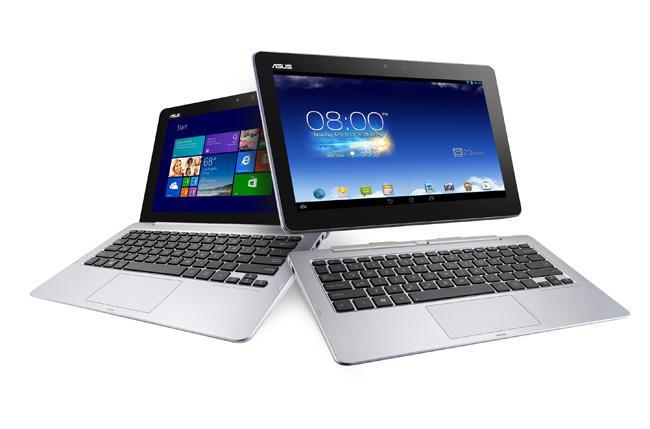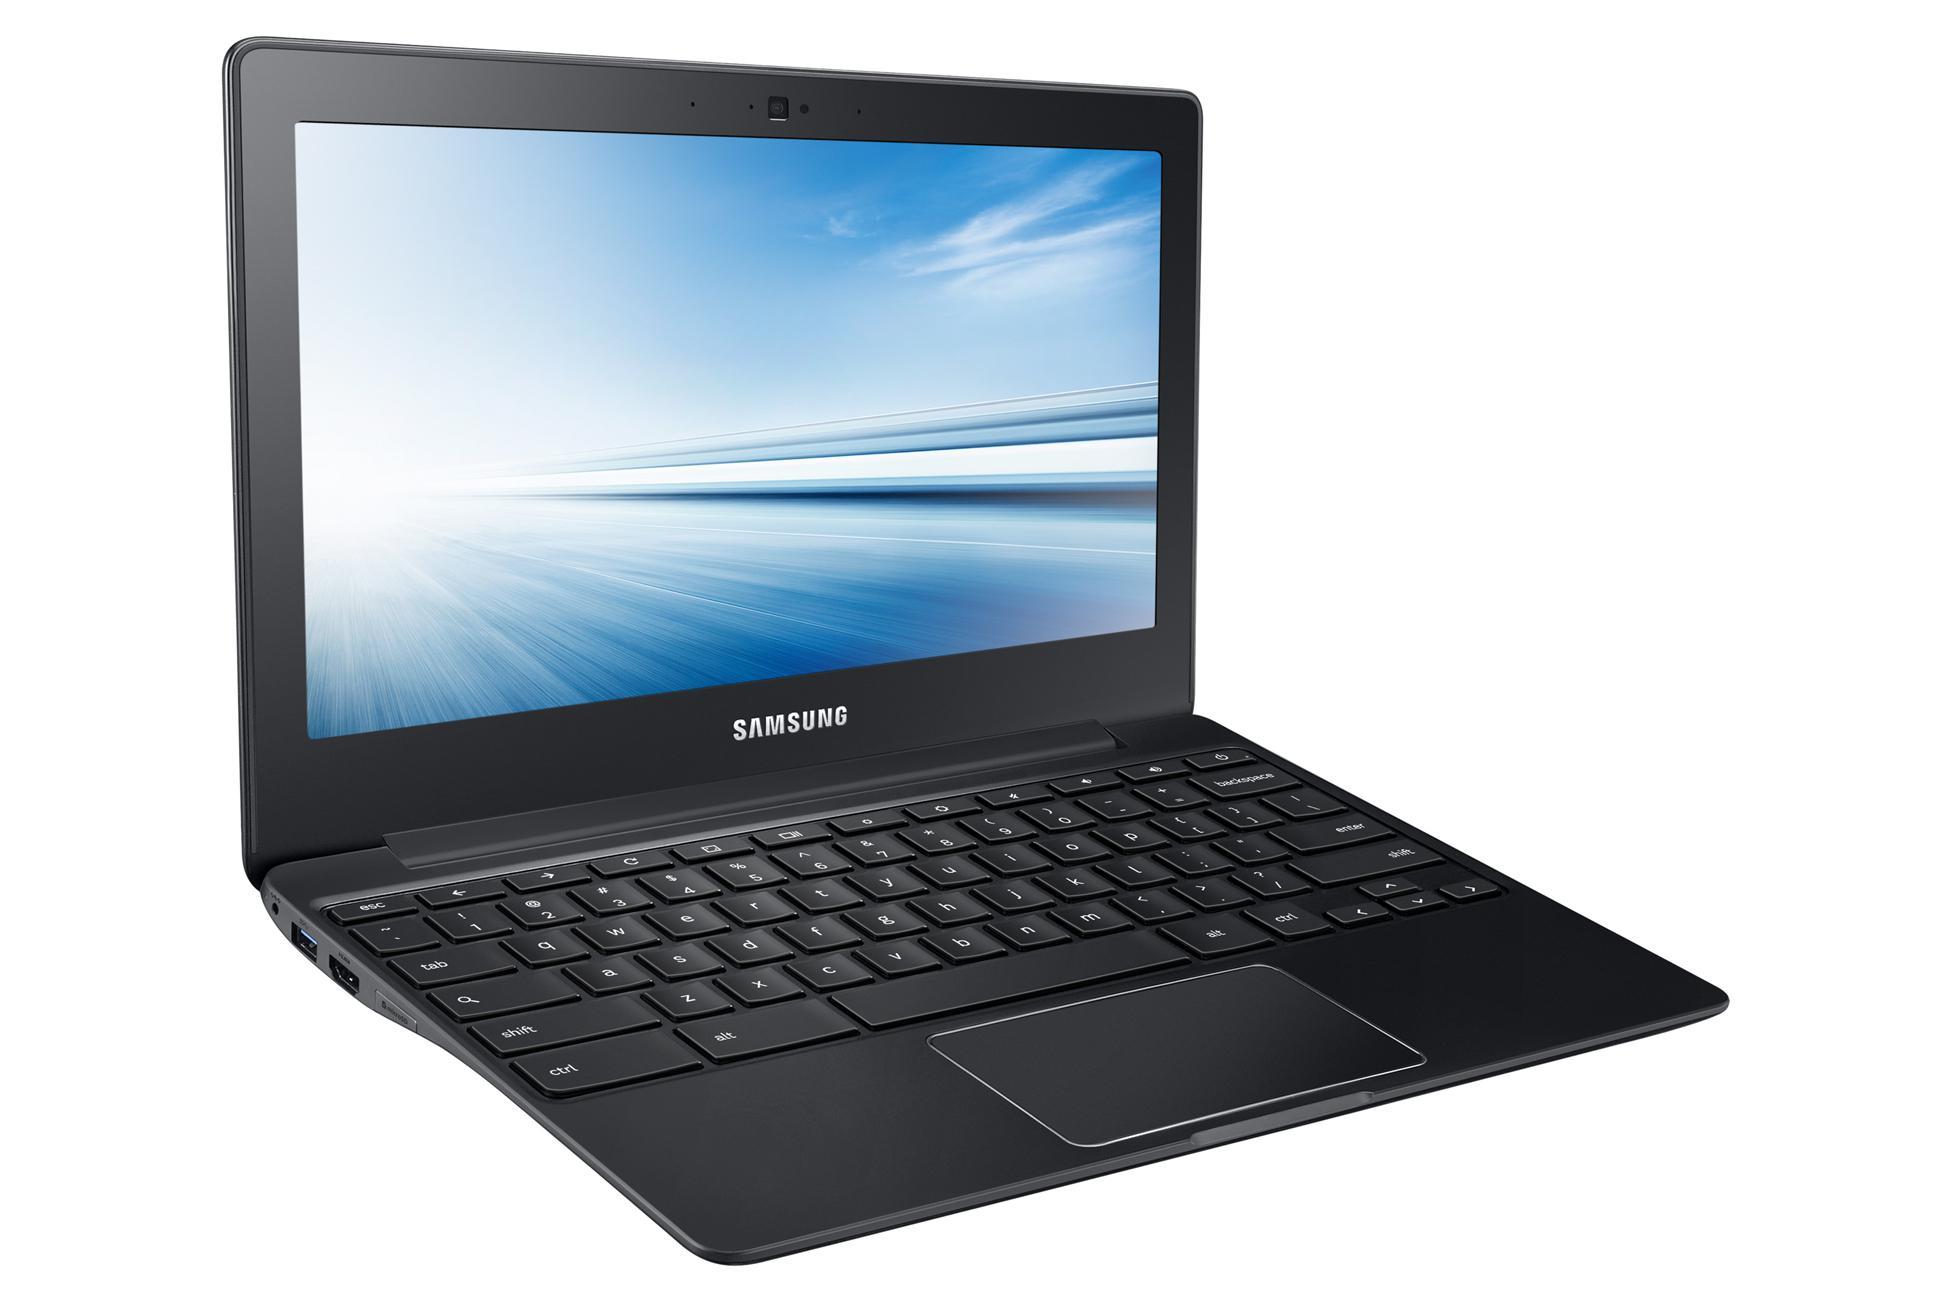The first image is the image on the left, the second image is the image on the right. For the images shown, is this caption "One laptop is shown with the monitor and keyboard disconnected from each other." true? Answer yes or no. Yes. The first image is the image on the left, the second image is the image on the right. Examine the images to the left and right. Is the description "The left image contains at least two laptop computers." accurate? Answer yes or no. Yes. 